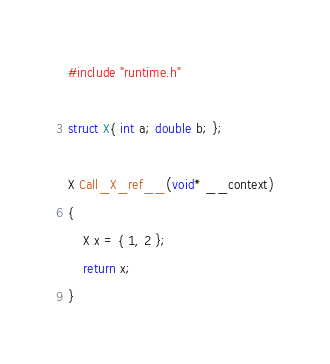Convert code to text. <code><loc_0><loc_0><loc_500><loc_500><_C++_>#include "runtime.h"

struct X{ int a; double b; };

X Call_X_ref__(void* __context)
{
	X x = { 1, 2 };
	return x;
}
</code> 